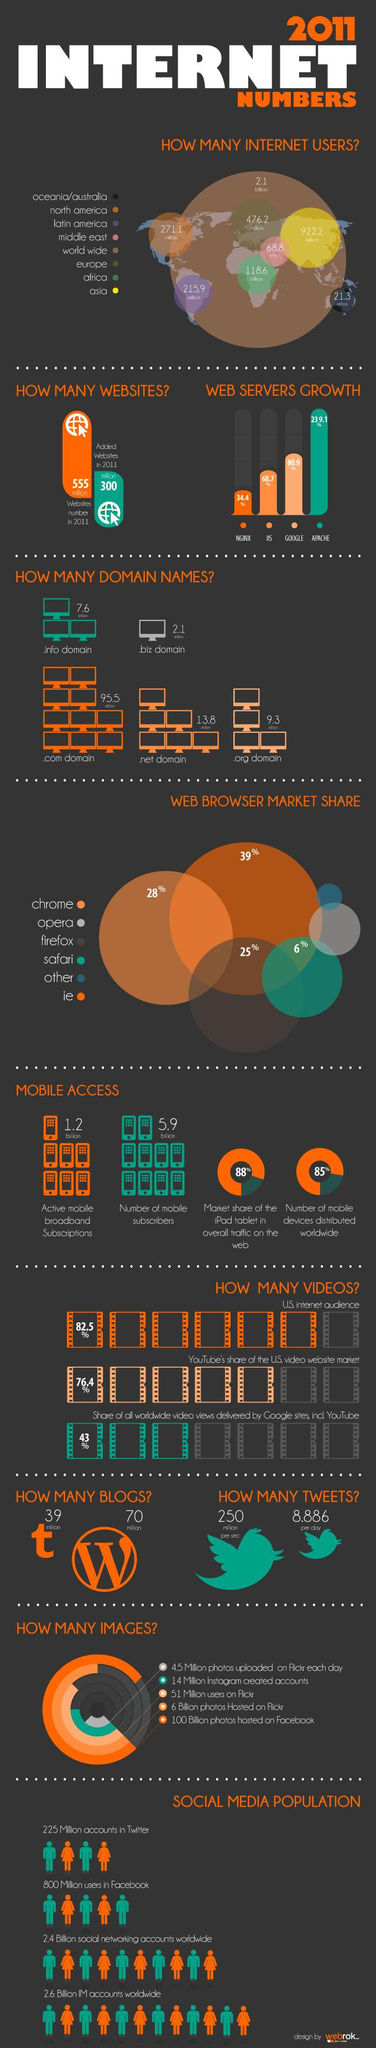List a handful of essential elements in this visual. Firefox has the third highest market share percentage among web browsers. According to the data, the growth percentage of the web server on Google was 80.9%. In 2011, there were approximately 922.2 million internet users in Asia. As of 2021, there were approximately 95.5 million .com domain names in existence. According to recent market share statistics, the second most popular web browser in use is Chrome. 